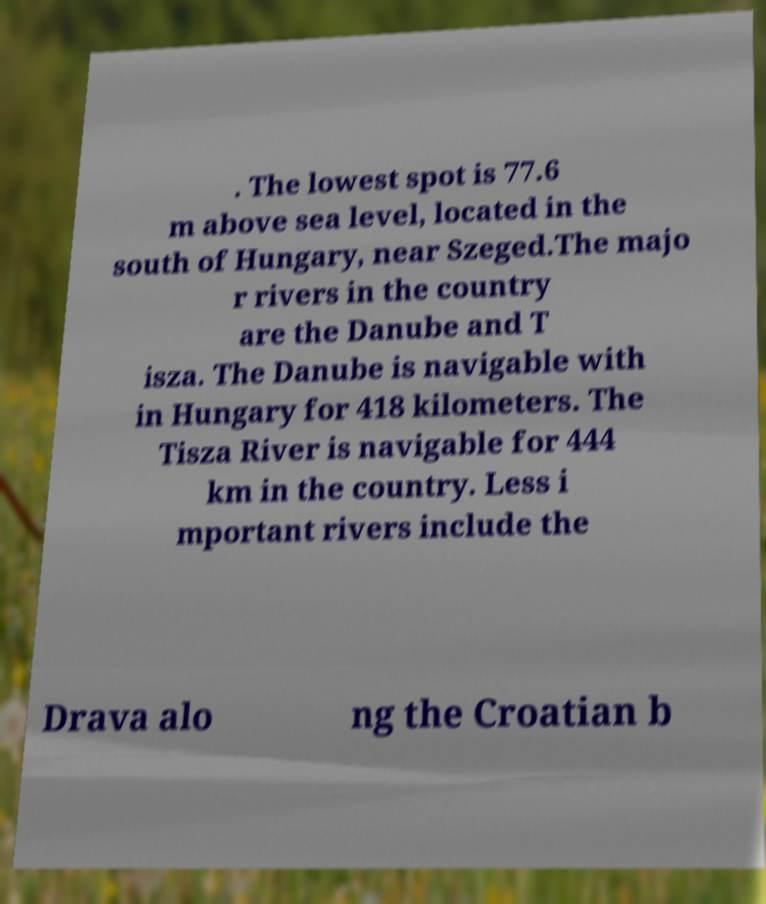For documentation purposes, I need the text within this image transcribed. Could you provide that? . The lowest spot is 77.6 m above sea level, located in the south of Hungary, near Szeged.The majo r rivers in the country are the Danube and T isza. The Danube is navigable with in Hungary for 418 kilometers. The Tisza River is navigable for 444 km in the country. Less i mportant rivers include the Drava alo ng the Croatian b 